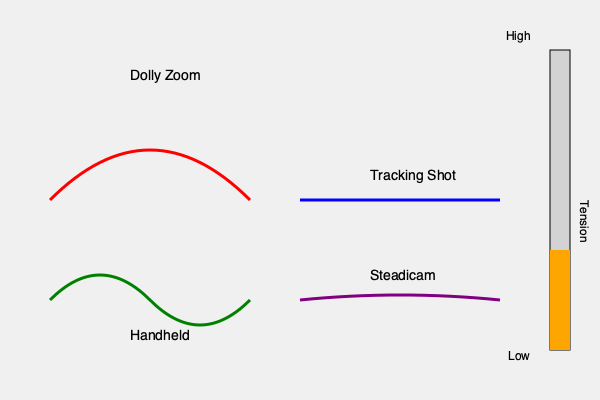Analyze the motion diagrams representing different camera movements. Which technique would be most effective for building tension in a high-stakes confrontation scene, and why does it surpass the others in creating a sense of unease? To determine the most effective camera movement for building tension in a high-stakes confrontation scene, let's analyze each technique:

1. Dolly Zoom (Red curve):
   - Creates a disorienting effect by simultaneously moving the camera and adjusting the zoom.
   - Distorts the background while keeping the subject stable.
   - Induces a sense of unease and psychological tension.

2. Tracking Shot (Blue line):
   - Follows the action smoothly, often used for revealing information gradually.
   - Can build anticipation but may feel too controlled for intense confrontations.

3. Handheld (Green wavy line):
   - Introduces instability and rawness to the scene.
   - Mimics a documentary-style approach, adding immediacy and unpredictability.
   - Can be disorienting if overused.

4. Steadicam (Purple smooth curve):
   - Provides smooth movement while allowing for complex camera paths.
   - Balances stability with mobility, but may lack the intensity needed for high tension.

Considering the high-stakes nature of the scene and the need to build tension, the Dolly Zoom technique stands out as the most effective for several reasons:

1. Psychological impact: The Dolly Zoom creates a visual distortion that directly affects the viewer's perception, inducing a feeling of unease or vertigo.

2. Symbolic representation: The technique can visually represent a character's internal state, such as fear or realization of danger.

3. Uniqueness: Its distinctive look immediately signals to the audience that something significant is happening.

4. Versatility: It can be adjusted to gradually increase tension by controlling the speed and extent of the zoom effect.

5. Subconscious effect: Unlike more obvious techniques like handheld, the Dolly Zoom can create tension without the audience being fully aware of the technique being used.

While other techniques have their merits (handheld for immediacy, tracking for reveal, steadicam for fluidity), the Dolly Zoom's ability to manipulate space and create a visceral, psychological reaction makes it particularly suited for building tension in a high-stakes confrontation scene.
Answer: Dolly Zoom, due to its psychological impact and spatial distortion. 